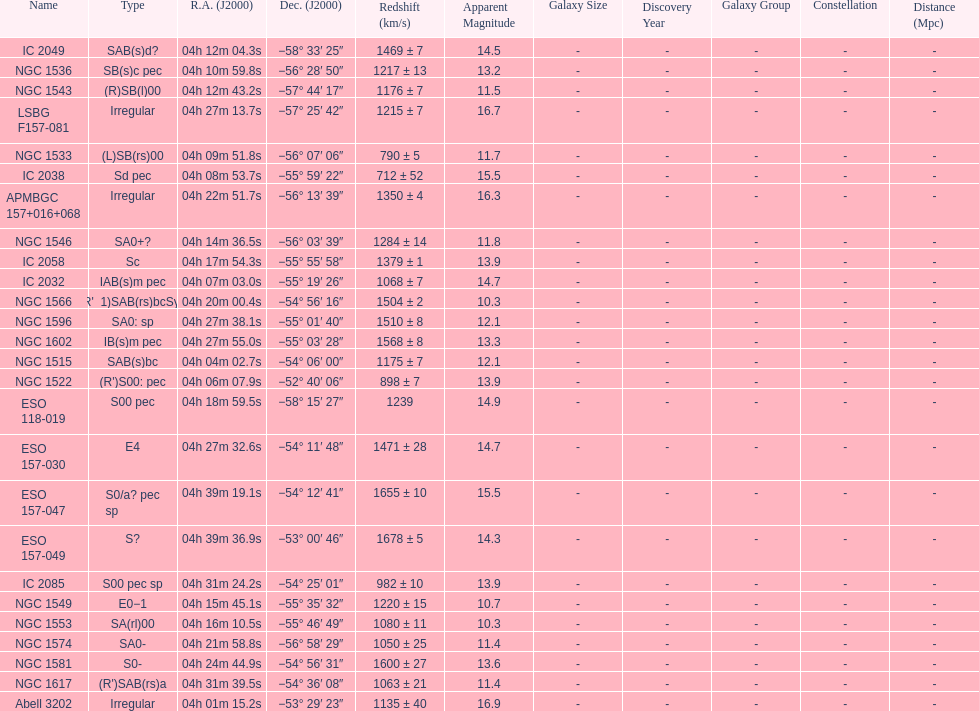Name the member with the highest apparent magnitude. Abell 3202. 